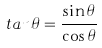Convert formula to latex. <formula><loc_0><loc_0><loc_500><loc_500>t a n \theta = \frac { \sin \theta } { \cos \theta }</formula> 